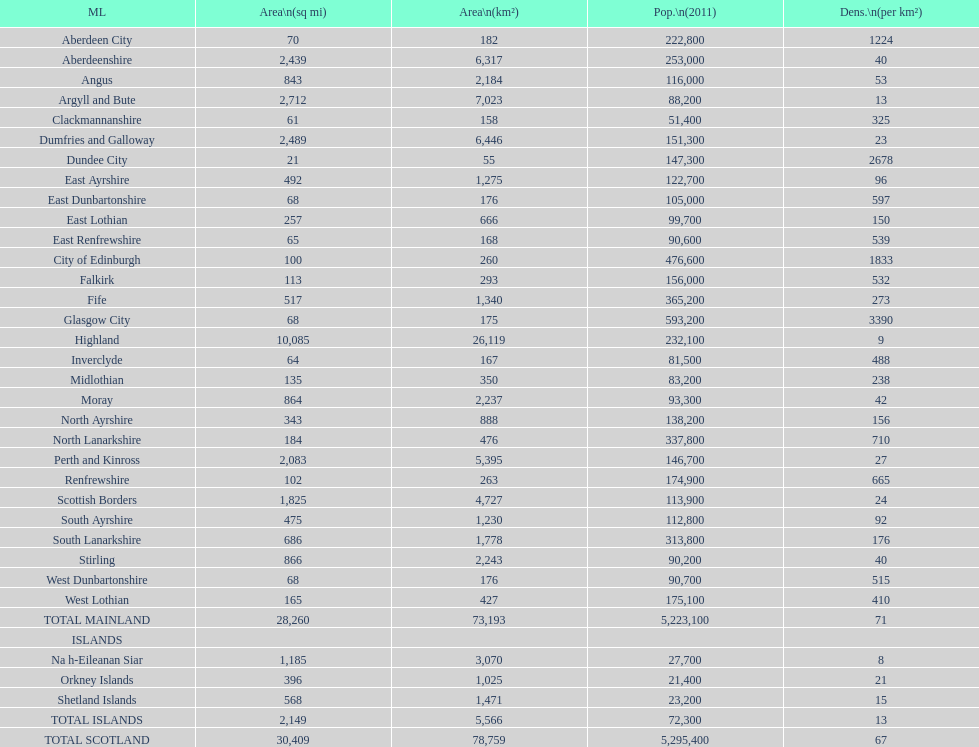What is the difference in square miles from angus and fife? 326. 